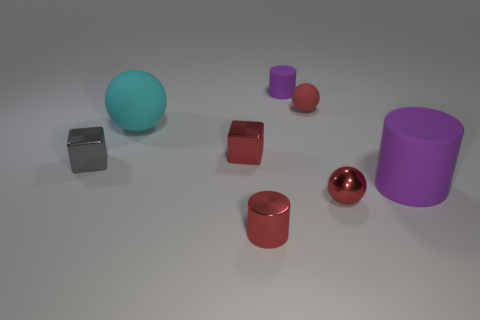Subtract 1 cylinders. How many cylinders are left? 2 Subtract all tiny balls. How many balls are left? 1 Add 1 tiny red objects. How many objects exist? 9 Subtract all blocks. How many objects are left? 6 Subtract 0 blue cylinders. How many objects are left? 8 Subtract all small shiny spheres. Subtract all metal cylinders. How many objects are left? 6 Add 7 red metal cylinders. How many red metal cylinders are left? 8 Add 2 big cyan matte balls. How many big cyan matte balls exist? 3 